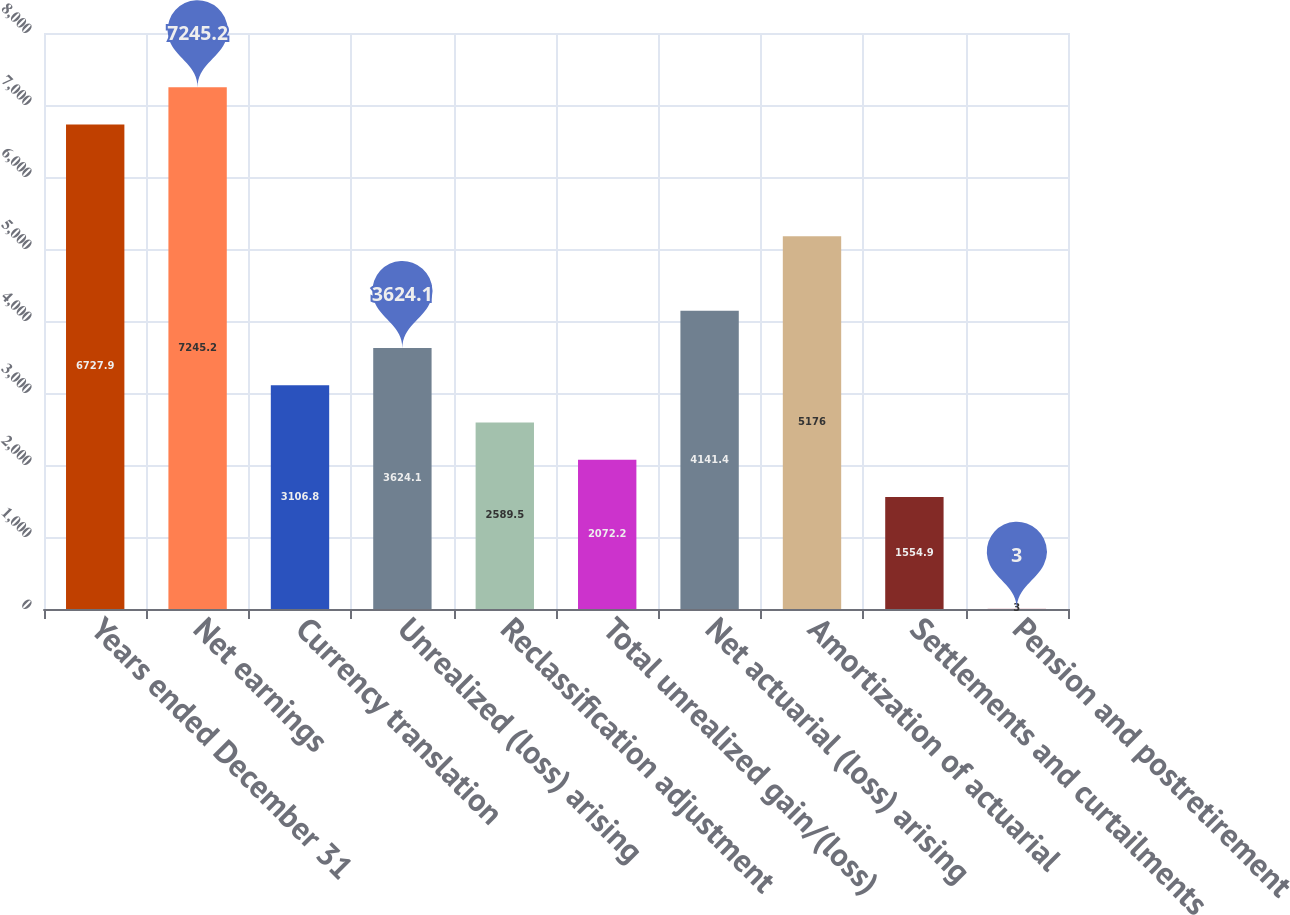Convert chart to OTSL. <chart><loc_0><loc_0><loc_500><loc_500><bar_chart><fcel>Years ended December 31<fcel>Net earnings<fcel>Currency translation<fcel>Unrealized (loss) arising<fcel>Reclassification adjustment<fcel>Total unrealized gain/(loss)<fcel>Net actuarial (loss) arising<fcel>Amortization of actuarial<fcel>Settlements and curtailments<fcel>Pension and postretirement<nl><fcel>6727.9<fcel>7245.2<fcel>3106.8<fcel>3624.1<fcel>2589.5<fcel>2072.2<fcel>4141.4<fcel>5176<fcel>1554.9<fcel>3<nl></chart> 